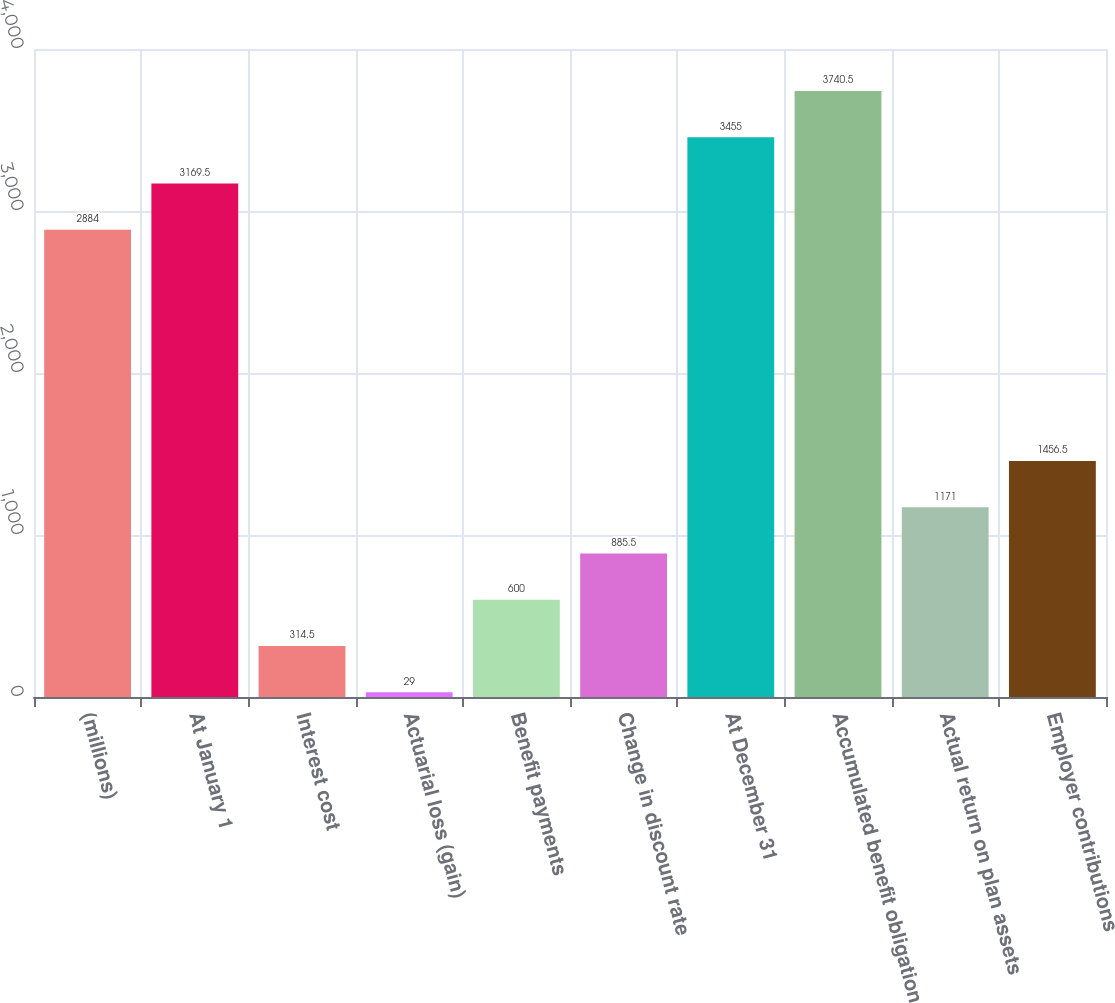<chart> <loc_0><loc_0><loc_500><loc_500><bar_chart><fcel>(millions)<fcel>At January 1<fcel>Interest cost<fcel>Actuarial loss (gain)<fcel>Benefit payments<fcel>Change in discount rate<fcel>At December 31<fcel>Accumulated benefit obligation<fcel>Actual return on plan assets<fcel>Employer contributions<nl><fcel>2884<fcel>3169.5<fcel>314.5<fcel>29<fcel>600<fcel>885.5<fcel>3455<fcel>3740.5<fcel>1171<fcel>1456.5<nl></chart> 